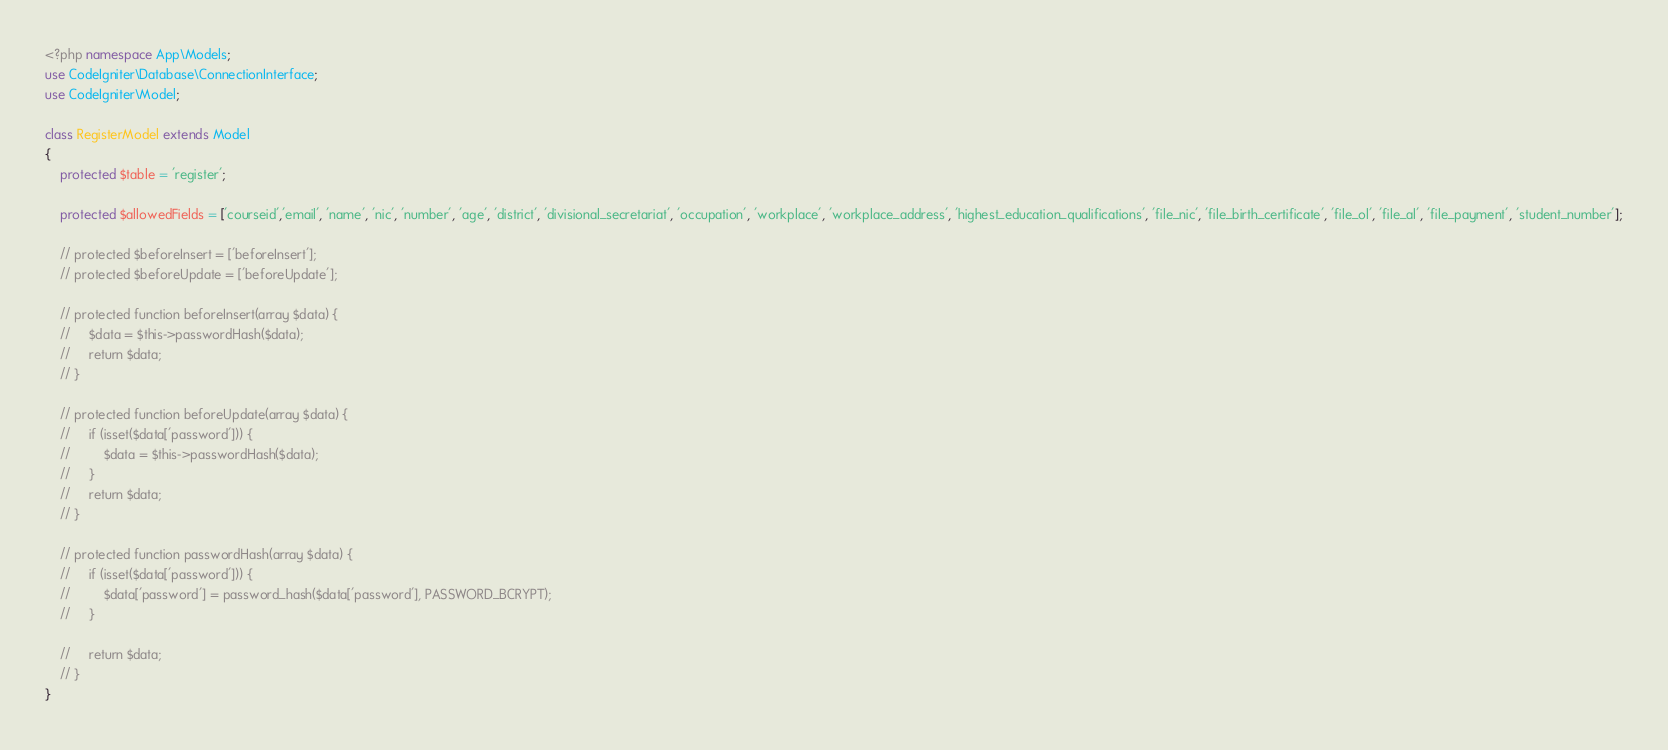<code> <loc_0><loc_0><loc_500><loc_500><_PHP_><?php namespace App\Models;
use CodeIgniter\Database\ConnectionInterface;
use CodeIgniter\Model;
 
class RegisterModel extends Model
{
    protected $table = 'register';

    protected $allowedFields = ['courseid','email', 'name', 'nic', 'number', 'age', 'district', 'divisional_secretariat', 'occupation', 'workplace', 'workplace_address', 'highest_education_qualifications', 'file_nic', 'file_birth_certificate', 'file_ol', 'file_al', 'file_payment', 'student_number'];

    // protected $beforeInsert = ['beforeInsert'];
    // protected $beforeUpdate = ['beforeUpdate'];

    // protected function beforeInsert(array $data) {
    //     $data = $this->passwordHash($data);
    //     return $data;
    // }
    
    // protected function beforeUpdate(array $data) {
    //     if (isset($data['password'])) {
    //         $data = $this->passwordHash($data);
    //     }
    //     return $data;
    // }

    // protected function passwordHash(array $data) {
    //     if (isset($data['password'])) {
    //         $data['password'] = password_hash($data['password'], PASSWORD_BCRYPT);
    //     }

    //     return $data;
    // }
}</code> 